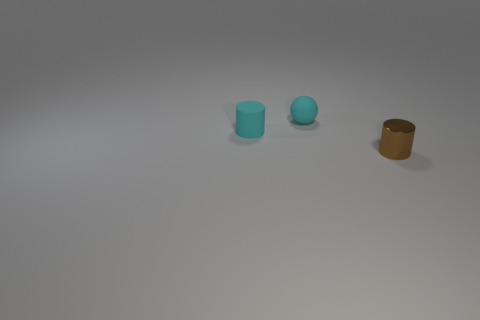Do the cylinder to the left of the metallic cylinder and the sphere have the same material?
Ensure brevity in your answer.  Yes. There is a small cyan object that is to the right of the cylinder behind the brown thing; what is its material?
Provide a short and direct response. Rubber. Are there more tiny cyan rubber things that are right of the cyan matte cylinder than cylinders in front of the small brown cylinder?
Give a very brief answer. Yes. How big is the cyan sphere?
Offer a terse response. Small. Does the object that is behind the small cyan cylinder have the same color as the rubber cylinder?
Make the answer very short. Yes. Is there anything else that has the same shape as the brown thing?
Keep it short and to the point. Yes. Is there a thing that is in front of the small cylinder that is left of the brown object?
Give a very brief answer. Yes. Are there fewer tiny cyan rubber things that are to the left of the cyan cylinder than small cylinders that are on the left side of the tiny metallic cylinder?
Your answer should be compact. Yes. There is a matte thing in front of the thing behind the tiny cyan object in front of the cyan matte sphere; how big is it?
Your answer should be compact. Small. Do the matte object that is in front of the rubber ball and the cyan ball have the same size?
Offer a very short reply. Yes. 